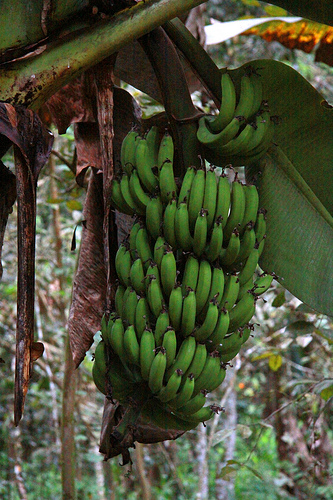Please provide the bounding box coordinate of the region this sentence describes: The banana is green. The coordinates that frame the green banana in the image are [0.54, 0.41, 0.58, 0.53]. 